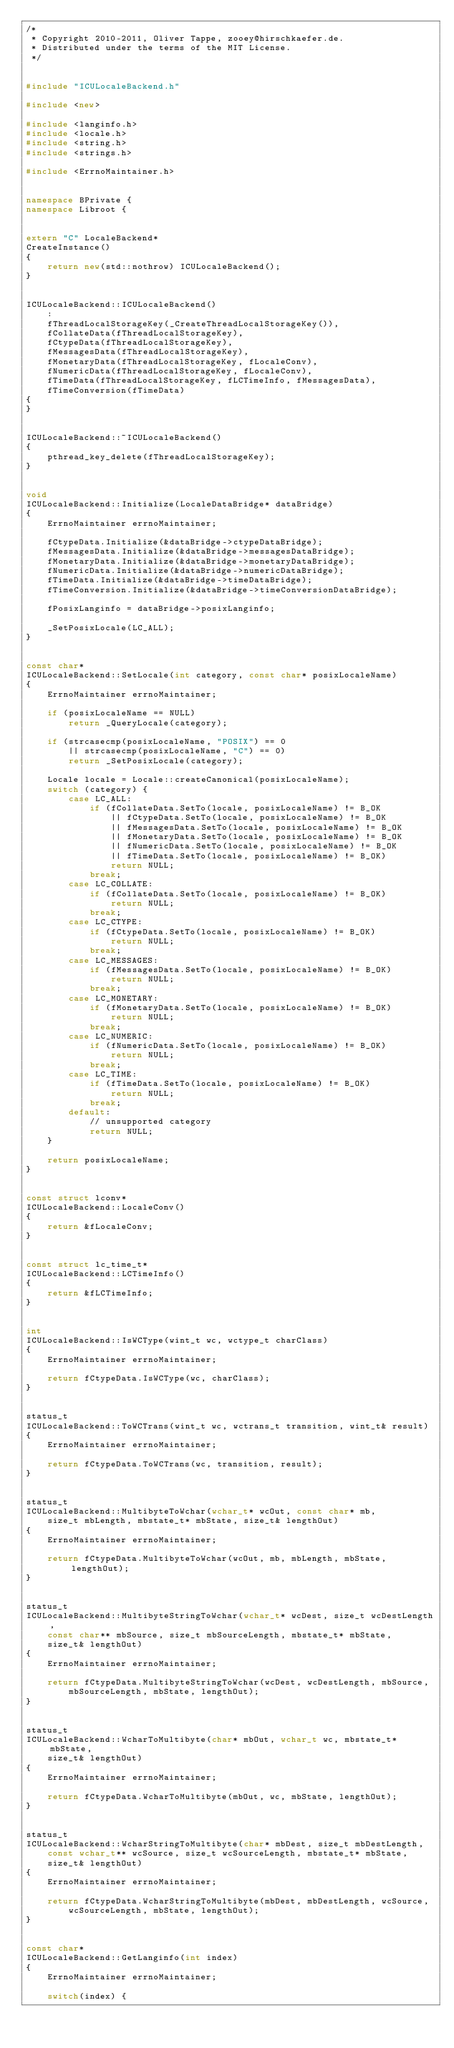Convert code to text. <code><loc_0><loc_0><loc_500><loc_500><_C++_>/*
 * Copyright 2010-2011, Oliver Tappe, zooey@hirschkaefer.de.
 * Distributed under the terms of the MIT License.
 */


#include "ICULocaleBackend.h"

#include <new>

#include <langinfo.h>
#include <locale.h>
#include <string.h>
#include <strings.h>

#include <ErrnoMaintainer.h>


namespace BPrivate {
namespace Libroot {


extern "C" LocaleBackend*
CreateInstance()
{
	return new(std::nothrow) ICULocaleBackend();
}


ICULocaleBackend::ICULocaleBackend()
	:
	fThreadLocalStorageKey(_CreateThreadLocalStorageKey()),
	fCollateData(fThreadLocalStorageKey),
	fCtypeData(fThreadLocalStorageKey),
	fMessagesData(fThreadLocalStorageKey),
	fMonetaryData(fThreadLocalStorageKey, fLocaleConv),
	fNumericData(fThreadLocalStorageKey, fLocaleConv),
	fTimeData(fThreadLocalStorageKey, fLCTimeInfo, fMessagesData),
	fTimeConversion(fTimeData)
{
}


ICULocaleBackend::~ICULocaleBackend()
{
	pthread_key_delete(fThreadLocalStorageKey);
}


void
ICULocaleBackend::Initialize(LocaleDataBridge* dataBridge)
{
	ErrnoMaintainer errnoMaintainer;

	fCtypeData.Initialize(&dataBridge->ctypeDataBridge);
	fMessagesData.Initialize(&dataBridge->messagesDataBridge);
	fMonetaryData.Initialize(&dataBridge->monetaryDataBridge);
	fNumericData.Initialize(&dataBridge->numericDataBridge);
	fTimeData.Initialize(&dataBridge->timeDataBridge);
	fTimeConversion.Initialize(&dataBridge->timeConversionDataBridge);

	fPosixLanginfo = dataBridge->posixLanginfo;

	_SetPosixLocale(LC_ALL);
}


const char*
ICULocaleBackend::SetLocale(int category, const char* posixLocaleName)
{
	ErrnoMaintainer errnoMaintainer;

	if (posixLocaleName == NULL)
		return _QueryLocale(category);

	if (strcasecmp(posixLocaleName, "POSIX") == 0
		|| strcasecmp(posixLocaleName, "C") == 0)
		return _SetPosixLocale(category);

	Locale locale = Locale::createCanonical(posixLocaleName);
	switch (category) {
		case LC_ALL:
			if (fCollateData.SetTo(locale, posixLocaleName) != B_OK
				|| fCtypeData.SetTo(locale, posixLocaleName) != B_OK
				|| fMessagesData.SetTo(locale, posixLocaleName) != B_OK
				|| fMonetaryData.SetTo(locale, posixLocaleName) != B_OK
				|| fNumericData.SetTo(locale, posixLocaleName) != B_OK
				|| fTimeData.SetTo(locale, posixLocaleName) != B_OK)
				return NULL;
			break;
		case LC_COLLATE:
			if (fCollateData.SetTo(locale, posixLocaleName) != B_OK)
				return NULL;
			break;
		case LC_CTYPE:
			if (fCtypeData.SetTo(locale, posixLocaleName) != B_OK)
				return NULL;
			break;
		case LC_MESSAGES:
			if (fMessagesData.SetTo(locale, posixLocaleName) != B_OK)
				return NULL;
			break;
		case LC_MONETARY:
			if (fMonetaryData.SetTo(locale, posixLocaleName) != B_OK)
				return NULL;
			break;
		case LC_NUMERIC:
			if (fNumericData.SetTo(locale, posixLocaleName) != B_OK)
				return NULL;
			break;
		case LC_TIME:
			if (fTimeData.SetTo(locale, posixLocaleName) != B_OK)
				return NULL;
			break;
		default:
			// unsupported category
			return NULL;
	}

	return posixLocaleName;
}


const struct lconv*
ICULocaleBackend::LocaleConv()
{
	return &fLocaleConv;
}


const struct lc_time_t*
ICULocaleBackend::LCTimeInfo()
{
	return &fLCTimeInfo;
}


int
ICULocaleBackend::IsWCType(wint_t wc, wctype_t charClass)
{
	ErrnoMaintainer errnoMaintainer;

	return fCtypeData.IsWCType(wc, charClass);
}


status_t
ICULocaleBackend::ToWCTrans(wint_t wc, wctrans_t transition, wint_t& result)
{
	ErrnoMaintainer errnoMaintainer;

	return fCtypeData.ToWCTrans(wc, transition, result);
}


status_t
ICULocaleBackend::MultibyteToWchar(wchar_t* wcOut, const char* mb,
	size_t mbLength, mbstate_t* mbState, size_t& lengthOut)
{
	ErrnoMaintainer errnoMaintainer;

	return fCtypeData.MultibyteToWchar(wcOut, mb, mbLength, mbState, lengthOut);
}


status_t
ICULocaleBackend::MultibyteStringToWchar(wchar_t* wcDest, size_t wcDestLength,
	const char** mbSource, size_t mbSourceLength, mbstate_t* mbState,
	size_t& lengthOut)
{
	ErrnoMaintainer errnoMaintainer;

	return fCtypeData.MultibyteStringToWchar(wcDest, wcDestLength, mbSource,
		mbSourceLength, mbState, lengthOut);
}


status_t
ICULocaleBackend::WcharToMultibyte(char* mbOut, wchar_t wc, mbstate_t* mbState,
	size_t& lengthOut)
{
	ErrnoMaintainer errnoMaintainer;

	return fCtypeData.WcharToMultibyte(mbOut, wc, mbState, lengthOut);
}


status_t
ICULocaleBackend::WcharStringToMultibyte(char* mbDest, size_t mbDestLength,
	const wchar_t** wcSource, size_t wcSourceLength, mbstate_t* mbState,
	size_t& lengthOut)
{
	ErrnoMaintainer errnoMaintainer;

	return fCtypeData.WcharStringToMultibyte(mbDest, mbDestLength, wcSource,
		wcSourceLength, mbState, lengthOut);
}


const char*
ICULocaleBackend::GetLanginfo(int index)
{
	ErrnoMaintainer errnoMaintainer;

	switch(index) {</code> 